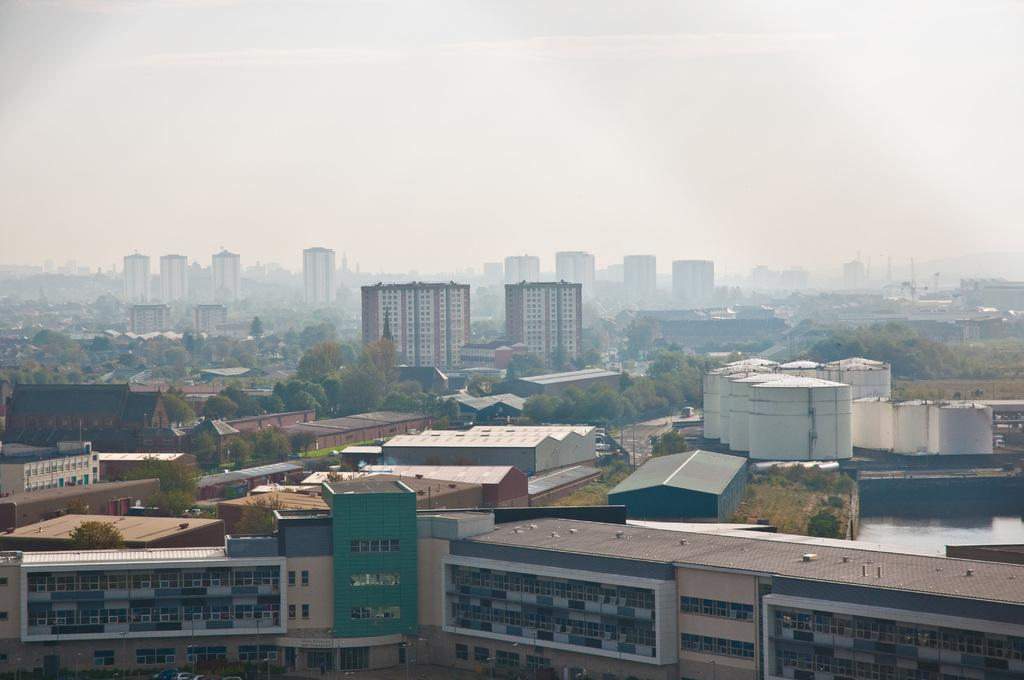What type of structures can be seen in the image? There are many buildings in the image. What other elements can be seen around the buildings? Trees are present around the buildings. What part of the natural environment is visible in the image? The sky is visible in the image. How many dinosaurs can be seen in the image? There are no dinosaurs present in the image. What type of beverage is being served in the image? There is no beverage, such as eggnog, present in the image. 